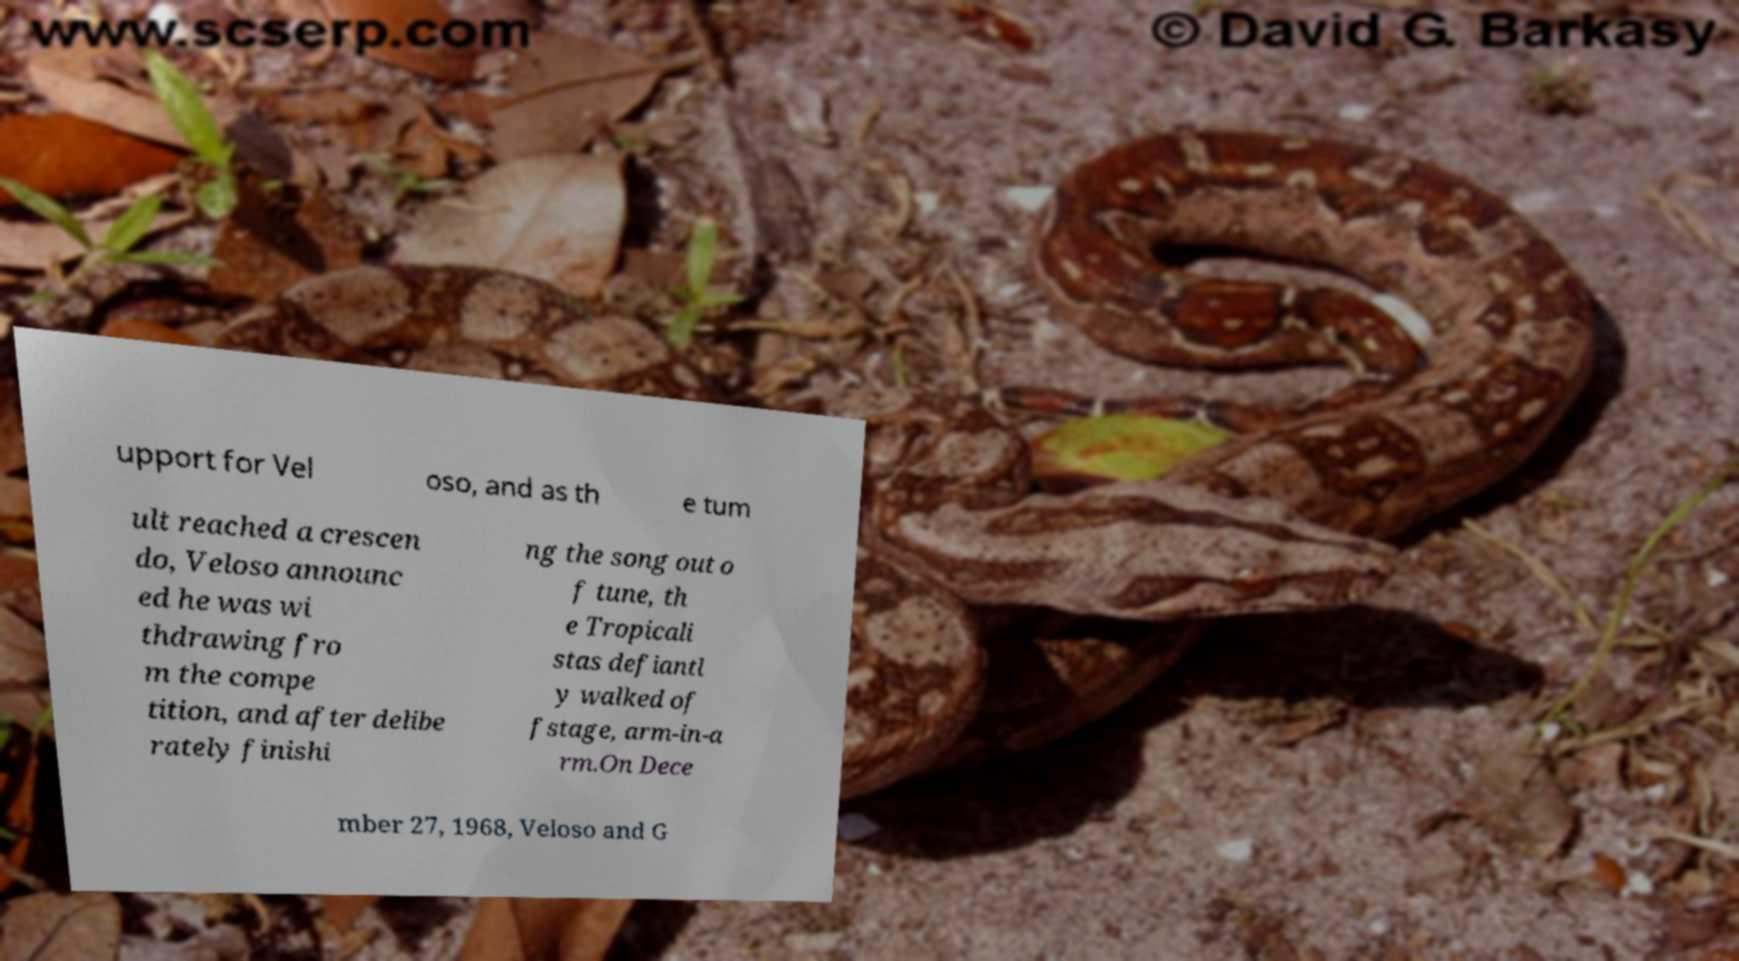Could you extract and type out the text from this image? upport for Vel oso, and as th e tum ult reached a crescen do, Veloso announc ed he was wi thdrawing fro m the compe tition, and after delibe rately finishi ng the song out o f tune, th e Tropicali stas defiantl y walked of fstage, arm-in-a rm.On Dece mber 27, 1968, Veloso and G 